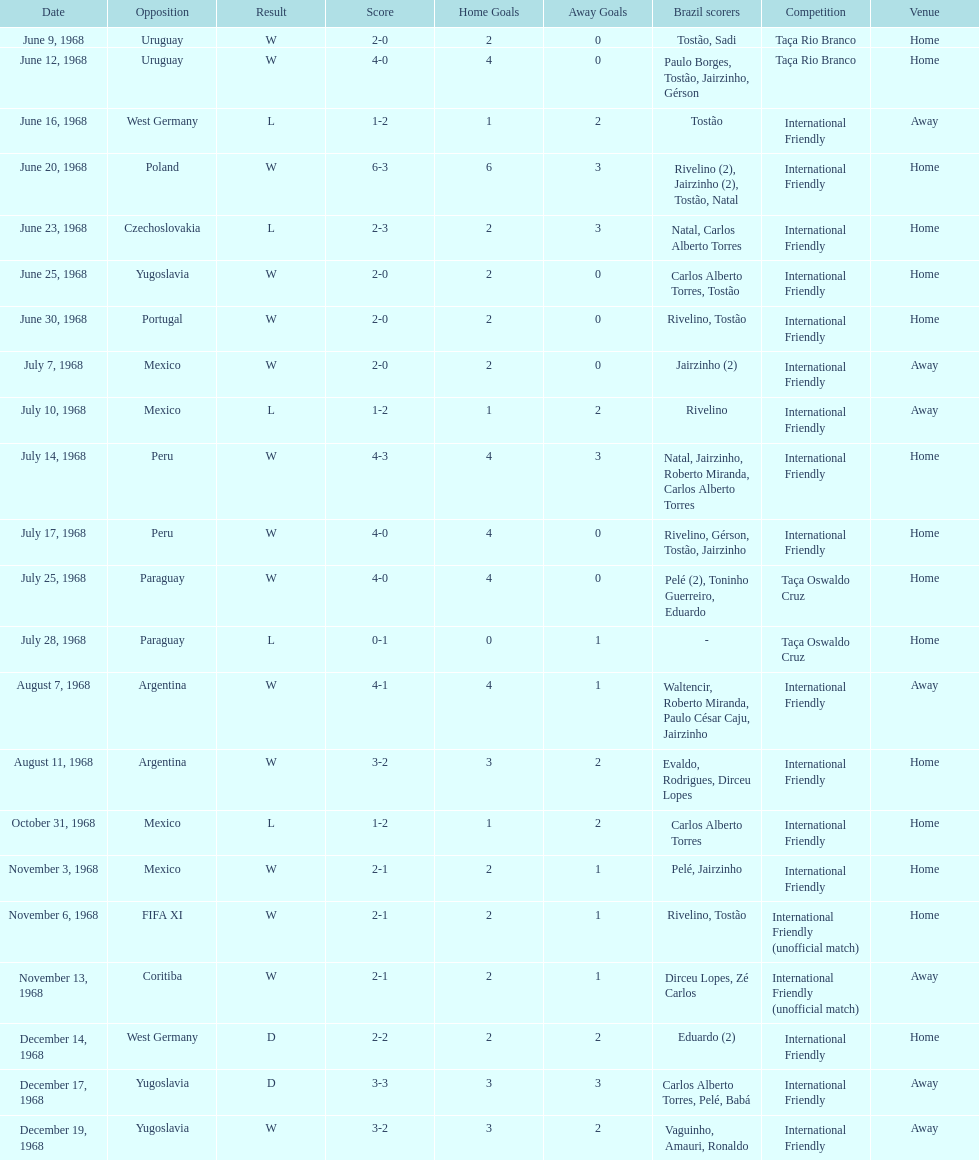What is the top score ever scored by the brazil national team? 6. Write the full table. {'header': ['Date', 'Opposition', 'Result', 'Score', 'Home Goals', 'Away Goals', 'Brazil scorers', 'Competition', 'Venue'], 'rows': [['June 9, 1968', 'Uruguay', 'W', '2-0', '2', '0', 'Tostão, Sadi', 'Taça Rio Branco', 'Home'], ['June 12, 1968', 'Uruguay', 'W', '4-0', '4', '0', 'Paulo Borges, Tostão, Jairzinho, Gérson', 'Taça Rio Branco', 'Home'], ['June 16, 1968', 'West Germany', 'L', '1-2', '1', '2', 'Tostão', 'International Friendly', 'Away'], ['June 20, 1968', 'Poland', 'W', '6-3', '6', '3', 'Rivelino (2), Jairzinho (2), Tostão, Natal', 'International Friendly', 'Home'], ['June 23, 1968', 'Czechoslovakia', 'L', '2-3', '2', '3', 'Natal, Carlos Alberto Torres', 'International Friendly', 'Home'], ['June 25, 1968', 'Yugoslavia', 'W', '2-0', '2', '0', 'Carlos Alberto Torres, Tostão', 'International Friendly', 'Home'], ['June 30, 1968', 'Portugal', 'W', '2-0', '2', '0', 'Rivelino, Tostão', 'International Friendly', 'Home'], ['July 7, 1968', 'Mexico', 'W', '2-0', '2', '0', 'Jairzinho (2)', 'International Friendly', 'Away'], ['July 10, 1968', 'Mexico', 'L', '1-2', '1', '2', 'Rivelino', 'International Friendly', 'Away'], ['July 14, 1968', 'Peru', 'W', '4-3', '4', '3', 'Natal, Jairzinho, Roberto Miranda, Carlos Alberto Torres', 'International Friendly', 'Home'], ['July 17, 1968', 'Peru', 'W', '4-0', '4', '0', 'Rivelino, Gérson, Tostão, Jairzinho', 'International Friendly', 'Home'], ['July 25, 1968', 'Paraguay', 'W', '4-0', '4', '0', 'Pelé (2), Toninho Guerreiro, Eduardo', 'Taça Oswaldo Cruz', 'Home'], ['July 28, 1968', 'Paraguay', 'L', '0-1', '0', '1', '-', 'Taça Oswaldo Cruz', 'Home'], ['August 7, 1968', 'Argentina', 'W', '4-1', '4', '1', 'Waltencir, Roberto Miranda, Paulo César Caju, Jairzinho', 'International Friendly', 'Away'], ['August 11, 1968', 'Argentina', 'W', '3-2', '3', '2', 'Evaldo, Rodrigues, Dirceu Lopes', 'International Friendly', 'Home'], ['October 31, 1968', 'Mexico', 'L', '1-2', '1', '2', 'Carlos Alberto Torres', 'International Friendly', 'Home'], ['November 3, 1968', 'Mexico', 'W', '2-1', '2', '1', 'Pelé, Jairzinho', 'International Friendly', 'Home'], ['November 6, 1968', 'FIFA XI', 'W', '2-1', '2', '1', 'Rivelino, Tostão', 'International Friendly (unofficial match)', 'Home'], ['November 13, 1968', 'Coritiba', 'W', '2-1', '2', '1', 'Dirceu Lopes, Zé Carlos', 'International Friendly (unofficial match)', 'Away'], ['December 14, 1968', 'West Germany', 'D', '2-2', '2', '2', 'Eduardo (2)', 'International Friendly', 'Home'], ['December 17, 1968', 'Yugoslavia', 'D', '3-3', '3', '3', 'Carlos Alberto Torres, Pelé, Babá', 'International Friendly', 'Away'], ['December 19, 1968', 'Yugoslavia', 'W', '3-2', '3', '2', 'Vaguinho, Amauri, Ronaldo', 'International Friendly', 'Away']]} 